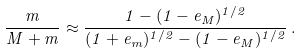Convert formula to latex. <formula><loc_0><loc_0><loc_500><loc_500>\frac { m } { M + m } \approx \frac { 1 - ( 1 - e _ { M } ) ^ { 1 / 2 } } { ( 1 + e _ { m } ) ^ { 1 / 2 } - ( 1 - e _ { M } ) ^ { 1 / 2 } } \, .</formula> 